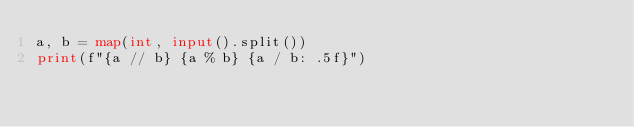Convert code to text. <code><loc_0><loc_0><loc_500><loc_500><_Python_>a, b = map(int, input().split())
print(f"{a // b} {a % b} {a / b: .5f}")
</code> 